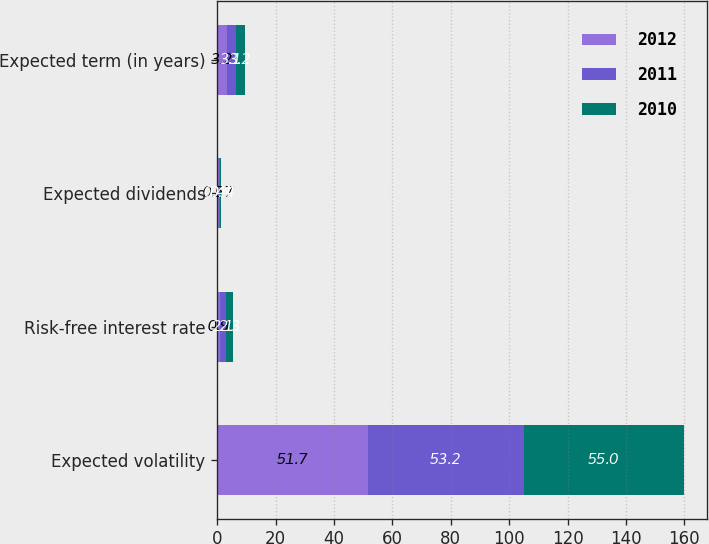Convert chart to OTSL. <chart><loc_0><loc_0><loc_500><loc_500><stacked_bar_chart><ecel><fcel>Expected volatility<fcel>Risk-free interest rate<fcel>Expected dividends<fcel>Expected term (in years)<nl><fcel>2012<fcel>51.7<fcel>0.9<fcel>0.57<fcel>3.2<nl><fcel>2011<fcel>53.2<fcel>2.1<fcel>0.44<fcel>3.1<nl><fcel>2010<fcel>55<fcel>2.3<fcel>0.4<fcel>3.2<nl></chart> 